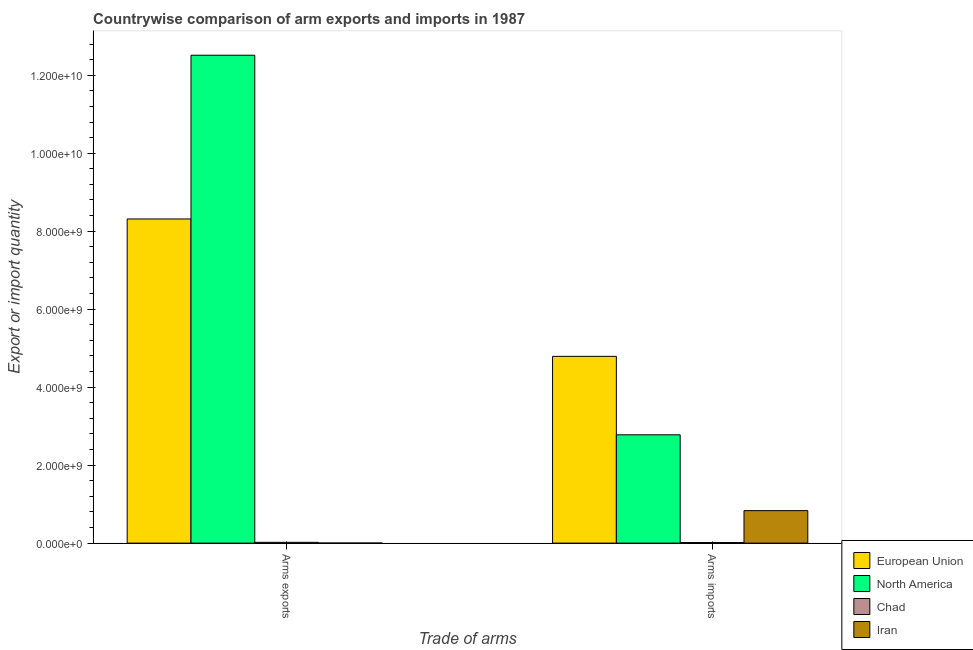How many different coloured bars are there?
Provide a succinct answer. 4. How many groups of bars are there?
Your response must be concise. 2. Are the number of bars per tick equal to the number of legend labels?
Provide a succinct answer. Yes. Are the number of bars on each tick of the X-axis equal?
Keep it short and to the point. Yes. What is the label of the 2nd group of bars from the left?
Offer a very short reply. Arms imports. What is the arms exports in Chad?
Make the answer very short. 2.00e+07. Across all countries, what is the maximum arms imports?
Offer a very short reply. 4.79e+09. Across all countries, what is the minimum arms exports?
Offer a terse response. 1.00e+06. In which country was the arms exports minimum?
Keep it short and to the point. Iran. What is the total arms imports in the graph?
Provide a succinct answer. 8.42e+09. What is the difference between the arms exports in Iran and that in European Union?
Offer a very short reply. -8.31e+09. What is the difference between the arms exports in North America and the arms imports in Iran?
Your answer should be very brief. 1.17e+1. What is the average arms exports per country?
Give a very brief answer. 5.21e+09. What is the difference between the arms imports and arms exports in Iran?
Provide a short and direct response. 8.32e+08. In how many countries, is the arms exports greater than 800000000 ?
Give a very brief answer. 2. What is the ratio of the arms imports in European Union to that in North America?
Give a very brief answer. 1.72. What does the 3rd bar from the left in Arms exports represents?
Make the answer very short. Chad. How many bars are there?
Your answer should be very brief. 8. Are all the bars in the graph horizontal?
Your answer should be compact. No. How many countries are there in the graph?
Your answer should be very brief. 4. Does the graph contain grids?
Your answer should be compact. No. How many legend labels are there?
Keep it short and to the point. 4. How are the legend labels stacked?
Provide a succinct answer. Vertical. What is the title of the graph?
Offer a very short reply. Countrywise comparison of arm exports and imports in 1987. Does "Cayman Islands" appear as one of the legend labels in the graph?
Offer a very short reply. No. What is the label or title of the X-axis?
Offer a terse response. Trade of arms. What is the label or title of the Y-axis?
Make the answer very short. Export or import quantity. What is the Export or import quantity of European Union in Arms exports?
Your answer should be very brief. 8.31e+09. What is the Export or import quantity of North America in Arms exports?
Your answer should be very brief. 1.25e+1. What is the Export or import quantity of European Union in Arms imports?
Give a very brief answer. 4.79e+09. What is the Export or import quantity in North America in Arms imports?
Your answer should be compact. 2.78e+09. What is the Export or import quantity of Chad in Arms imports?
Give a very brief answer. 1.50e+07. What is the Export or import quantity of Iran in Arms imports?
Make the answer very short. 8.33e+08. Across all Trade of arms, what is the maximum Export or import quantity in European Union?
Your answer should be compact. 8.31e+09. Across all Trade of arms, what is the maximum Export or import quantity in North America?
Provide a short and direct response. 1.25e+1. Across all Trade of arms, what is the maximum Export or import quantity in Chad?
Give a very brief answer. 2.00e+07. Across all Trade of arms, what is the maximum Export or import quantity in Iran?
Keep it short and to the point. 8.33e+08. Across all Trade of arms, what is the minimum Export or import quantity of European Union?
Give a very brief answer. 4.79e+09. Across all Trade of arms, what is the minimum Export or import quantity of North America?
Keep it short and to the point. 2.78e+09. Across all Trade of arms, what is the minimum Export or import quantity of Chad?
Ensure brevity in your answer.  1.50e+07. What is the total Export or import quantity of European Union in the graph?
Your response must be concise. 1.31e+1. What is the total Export or import quantity of North America in the graph?
Your answer should be very brief. 1.53e+1. What is the total Export or import quantity in Chad in the graph?
Provide a succinct answer. 3.50e+07. What is the total Export or import quantity in Iran in the graph?
Your answer should be compact. 8.34e+08. What is the difference between the Export or import quantity of European Union in Arms exports and that in Arms imports?
Offer a terse response. 3.52e+09. What is the difference between the Export or import quantity in North America in Arms exports and that in Arms imports?
Provide a succinct answer. 9.74e+09. What is the difference between the Export or import quantity in Iran in Arms exports and that in Arms imports?
Ensure brevity in your answer.  -8.32e+08. What is the difference between the Export or import quantity of European Union in Arms exports and the Export or import quantity of North America in Arms imports?
Your answer should be very brief. 5.54e+09. What is the difference between the Export or import quantity in European Union in Arms exports and the Export or import quantity in Chad in Arms imports?
Make the answer very short. 8.30e+09. What is the difference between the Export or import quantity of European Union in Arms exports and the Export or import quantity of Iran in Arms imports?
Your answer should be compact. 7.48e+09. What is the difference between the Export or import quantity of North America in Arms exports and the Export or import quantity of Chad in Arms imports?
Ensure brevity in your answer.  1.25e+1. What is the difference between the Export or import quantity of North America in Arms exports and the Export or import quantity of Iran in Arms imports?
Your answer should be very brief. 1.17e+1. What is the difference between the Export or import quantity of Chad in Arms exports and the Export or import quantity of Iran in Arms imports?
Offer a very short reply. -8.13e+08. What is the average Export or import quantity in European Union per Trade of arms?
Your response must be concise. 6.55e+09. What is the average Export or import quantity of North America per Trade of arms?
Make the answer very short. 7.65e+09. What is the average Export or import quantity in Chad per Trade of arms?
Keep it short and to the point. 1.75e+07. What is the average Export or import quantity in Iran per Trade of arms?
Offer a terse response. 4.17e+08. What is the difference between the Export or import quantity in European Union and Export or import quantity in North America in Arms exports?
Offer a terse response. -4.20e+09. What is the difference between the Export or import quantity in European Union and Export or import quantity in Chad in Arms exports?
Your answer should be very brief. 8.29e+09. What is the difference between the Export or import quantity of European Union and Export or import quantity of Iran in Arms exports?
Provide a short and direct response. 8.31e+09. What is the difference between the Export or import quantity of North America and Export or import quantity of Chad in Arms exports?
Ensure brevity in your answer.  1.25e+1. What is the difference between the Export or import quantity in North America and Export or import quantity in Iran in Arms exports?
Provide a succinct answer. 1.25e+1. What is the difference between the Export or import quantity of Chad and Export or import quantity of Iran in Arms exports?
Ensure brevity in your answer.  1.90e+07. What is the difference between the Export or import quantity in European Union and Export or import quantity in North America in Arms imports?
Keep it short and to the point. 2.01e+09. What is the difference between the Export or import quantity in European Union and Export or import quantity in Chad in Arms imports?
Your response must be concise. 4.78e+09. What is the difference between the Export or import quantity in European Union and Export or import quantity in Iran in Arms imports?
Provide a succinct answer. 3.96e+09. What is the difference between the Export or import quantity in North America and Export or import quantity in Chad in Arms imports?
Your answer should be compact. 2.76e+09. What is the difference between the Export or import quantity in North America and Export or import quantity in Iran in Arms imports?
Your answer should be compact. 1.94e+09. What is the difference between the Export or import quantity in Chad and Export or import quantity in Iran in Arms imports?
Your answer should be very brief. -8.18e+08. What is the ratio of the Export or import quantity in European Union in Arms exports to that in Arms imports?
Provide a short and direct response. 1.74. What is the ratio of the Export or import quantity of North America in Arms exports to that in Arms imports?
Your answer should be very brief. 4.5. What is the ratio of the Export or import quantity of Iran in Arms exports to that in Arms imports?
Offer a very short reply. 0. What is the difference between the highest and the second highest Export or import quantity in European Union?
Ensure brevity in your answer.  3.52e+09. What is the difference between the highest and the second highest Export or import quantity of North America?
Offer a very short reply. 9.74e+09. What is the difference between the highest and the second highest Export or import quantity in Iran?
Keep it short and to the point. 8.32e+08. What is the difference between the highest and the lowest Export or import quantity of European Union?
Make the answer very short. 3.52e+09. What is the difference between the highest and the lowest Export or import quantity in North America?
Your response must be concise. 9.74e+09. What is the difference between the highest and the lowest Export or import quantity in Chad?
Your answer should be compact. 5.00e+06. What is the difference between the highest and the lowest Export or import quantity of Iran?
Offer a very short reply. 8.32e+08. 